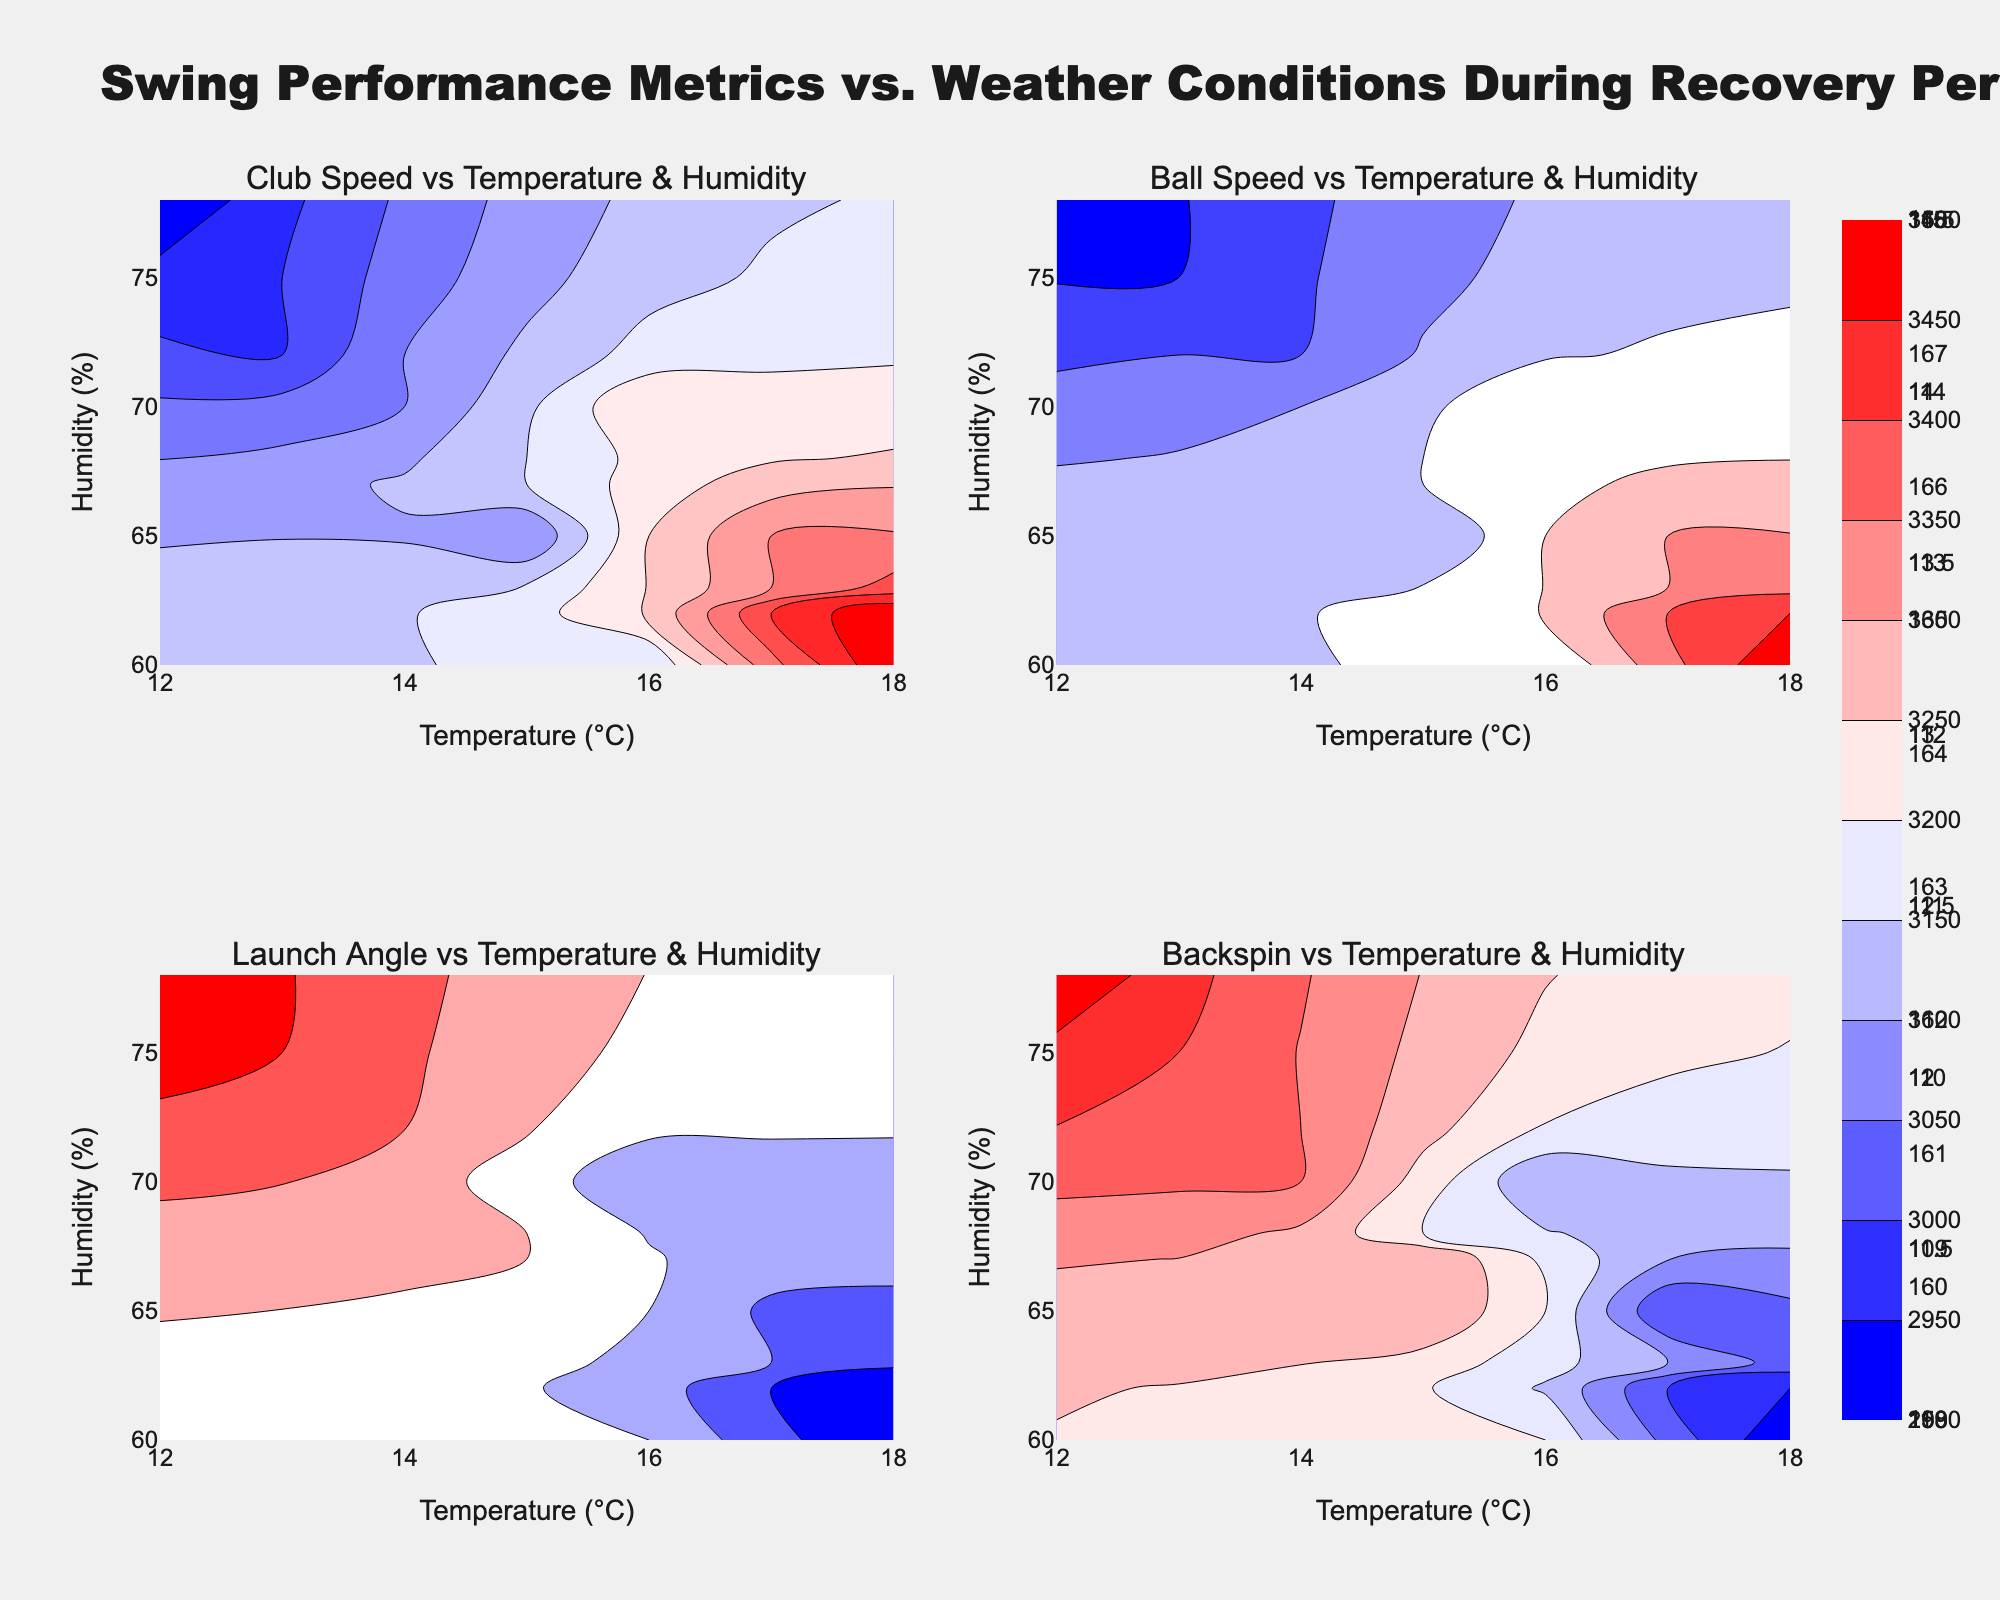What is the title of the figure? This question requires identifying the main title of the entire figure, which is typically positioned at the top.
Answer: Swing Performance Metrics vs. Weather Conditions During Recovery Period What is the x-axis label for all the subplots? The x-axis label is usually represented at the bottom of each plot. Here, we are looking at the temperatures in Celsius.
Answer: Temperature (°C) In the subplot showing ‘Launch Angle vs Temperature & Humidity,’ what color represents the highest values? The highest values in contour plots are often represented by the color at the end of the color scale (red in this case).
Answer: Red Which variable shows a noticeable peak at high temperatures in its respective subplot? To answer this, observe all subplots and identify which one shows a peak or higher concentration in contour lines in the higher temperature range. Based on general observation, this often pertains to metrics that improve with recovery.
Answer: Ball Speed Which subplot indicates the greatest variability in the data? The subplot with the most variation will show irregular, tightly packed contour lines indicating significant fluctuations.
Answer: Club Speed vs Temperature & Humidity How does the ‘Backspin’ generally change with increasing humidity in its respective subplot? Follow the contour lines in the subplot and observe the trend as humidity increases. The Backspin values tend to decrease or increase needs to be inferred.
Answer: Increases Are there any visible patterns between ‘Temperature’ and ‘Launch Angle’ in the respective subplot? Look closely at the contour lines to see if there is an apparent trend as the temperature changes. Since launch angle tends to be consistent, observe for slope or intensity of contour lines.
Answer: Launch angle slightly decreases with higher temperatures In the ‘Ball Speed vs Temperature & Humidity’ subplot, what is the approximate ball speed at 15°C and 70% humidity? Locate the intersection of 15°C temperature and 70% humidity on the Ball Speed subplot and read the contour line value.
Answer: Around 163 Compare the impact of temperature on 'Club Speed' and 'Ball Speed'. Which one shows more sensitivity to temperature changes? By examining the contour plot gradients, determine which subplot (Club Speed vs Ball Speed) shows steeper changes in values as temperature changes, indicating higher sensitivity.
Answer: Ball Speed 